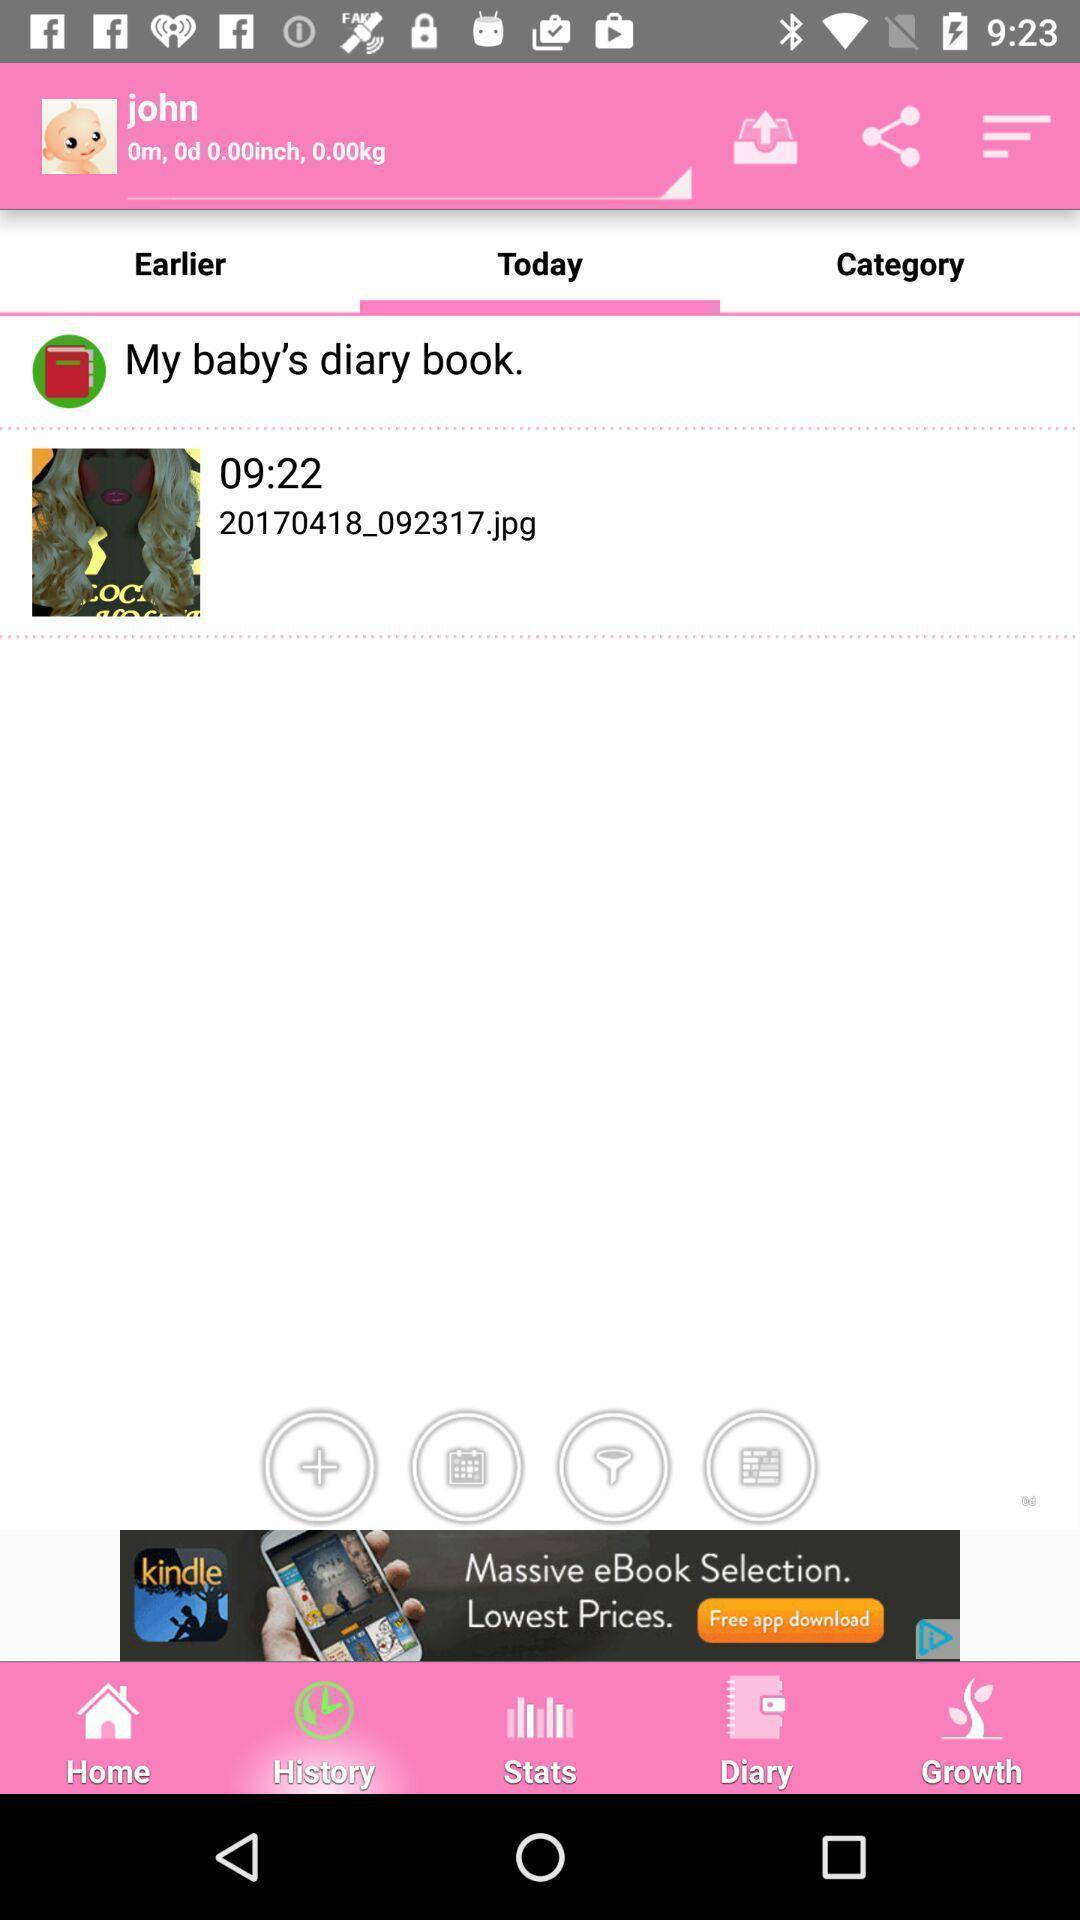Explain what's happening in this screen capture. Page displaying a jpg file. 